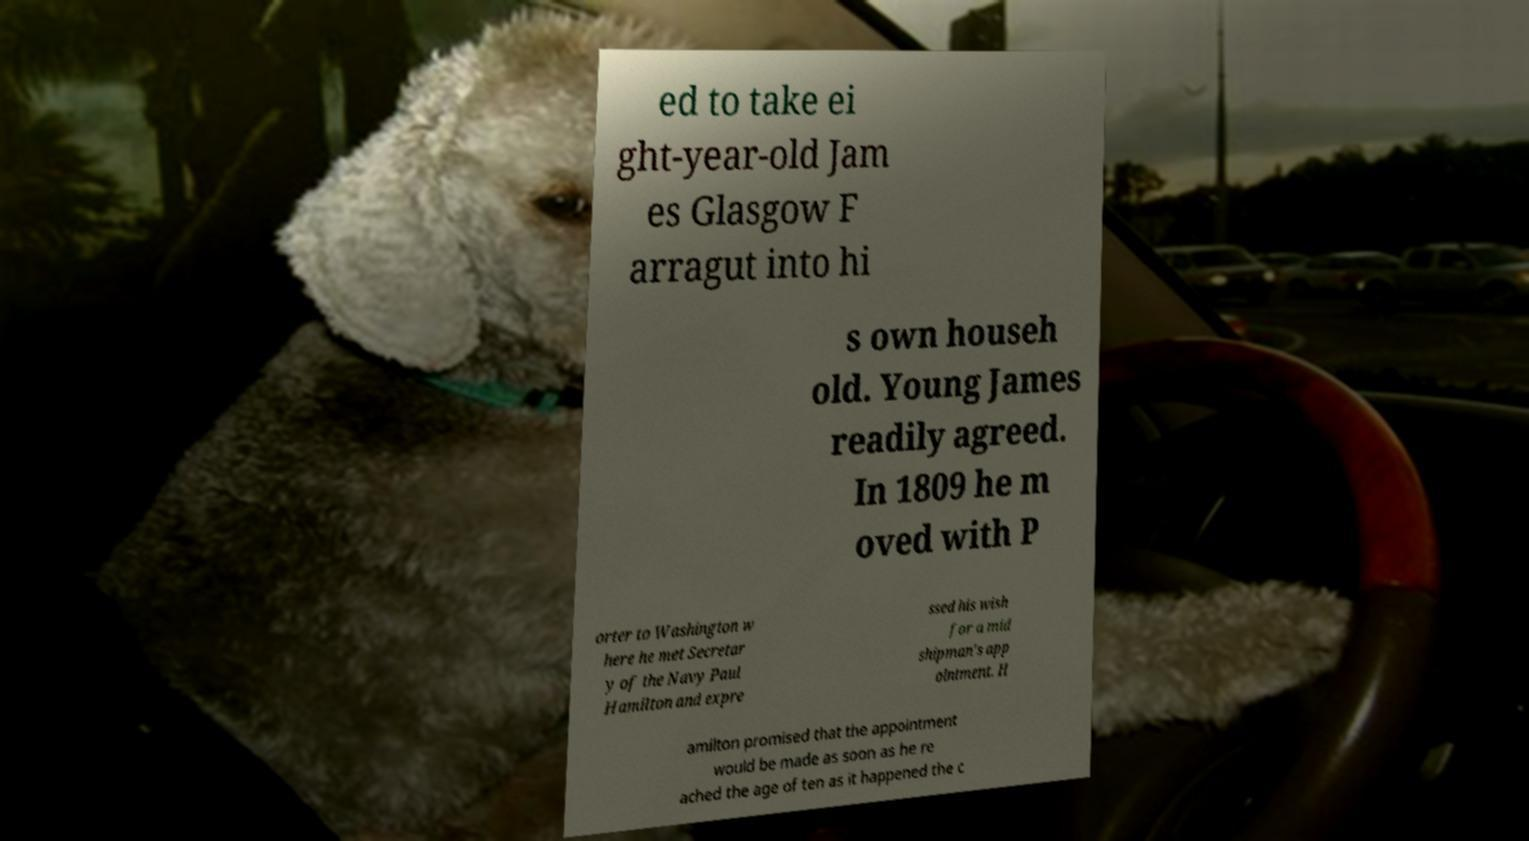Can you accurately transcribe the text from the provided image for me? ed to take ei ght-year-old Jam es Glasgow F arragut into hi s own househ old. Young James readily agreed. In 1809 he m oved with P orter to Washington w here he met Secretar y of the Navy Paul Hamilton and expre ssed his wish for a mid shipman's app ointment. H amilton promised that the appointment would be made as soon as he re ached the age of ten as it happened the c 